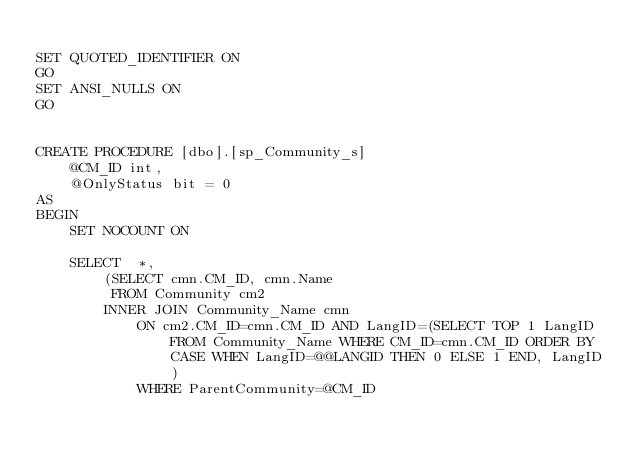<code> <loc_0><loc_0><loc_500><loc_500><_SQL_>
SET QUOTED_IDENTIFIER ON
GO
SET ANSI_NULLS ON
GO


CREATE PROCEDURE [dbo].[sp_Community_s] 
	@CM_ID int,
	@OnlyStatus bit = 0
AS
BEGIN
	SET NOCOUNT ON

	SELECT	*,
		(SELECT cmn.CM_ID, cmn.Name
		 FROM Community cm2
		INNER JOIN Community_Name cmn
			ON cm2.CM_ID=cmn.CM_ID AND LangID=(SELECT TOP 1 LangID FROM Community_Name WHERE CM_ID=cmn.CM_ID ORDER BY CASE WHEN LangID=@@LANGID THEN 0 ELSE 1 END, LangID)
			WHERE ParentCommunity=@CM_ID</code> 